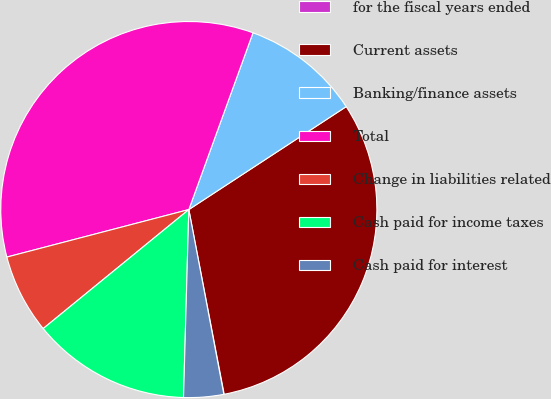<chart> <loc_0><loc_0><loc_500><loc_500><pie_chart><fcel>for the fiscal years ended<fcel>Current assets<fcel>Banking/finance assets<fcel>Total<fcel>Change in liabilities related<fcel>Cash paid for income taxes<fcel>Cash paid for interest<nl><fcel>0.03%<fcel>31.21%<fcel>10.24%<fcel>34.61%<fcel>6.84%<fcel>13.65%<fcel>3.43%<nl></chart> 